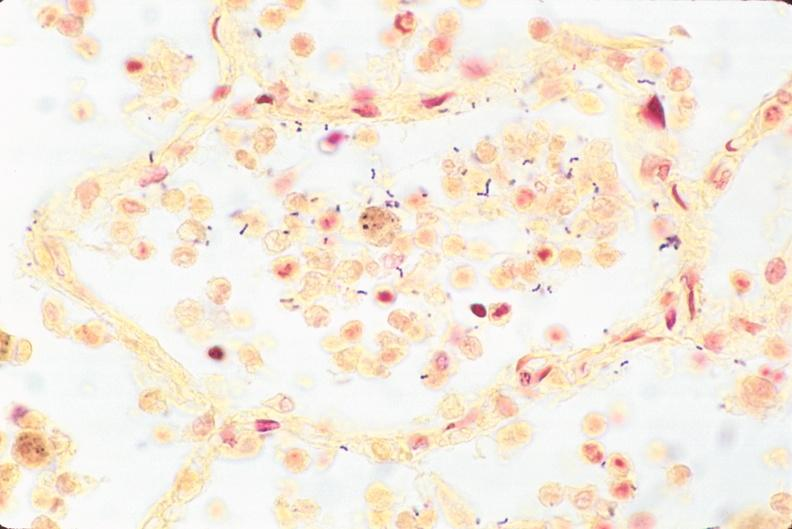s respiratory present?
Answer the question using a single word or phrase. Yes 